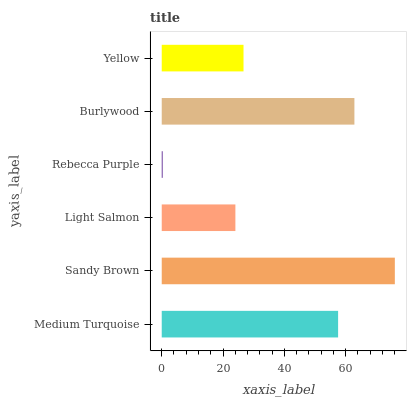Is Rebecca Purple the minimum?
Answer yes or no. Yes. Is Sandy Brown the maximum?
Answer yes or no. Yes. Is Light Salmon the minimum?
Answer yes or no. No. Is Light Salmon the maximum?
Answer yes or no. No. Is Sandy Brown greater than Light Salmon?
Answer yes or no. Yes. Is Light Salmon less than Sandy Brown?
Answer yes or no. Yes. Is Light Salmon greater than Sandy Brown?
Answer yes or no. No. Is Sandy Brown less than Light Salmon?
Answer yes or no. No. Is Medium Turquoise the high median?
Answer yes or no. Yes. Is Yellow the low median?
Answer yes or no. Yes. Is Rebecca Purple the high median?
Answer yes or no. No. Is Burlywood the low median?
Answer yes or no. No. 